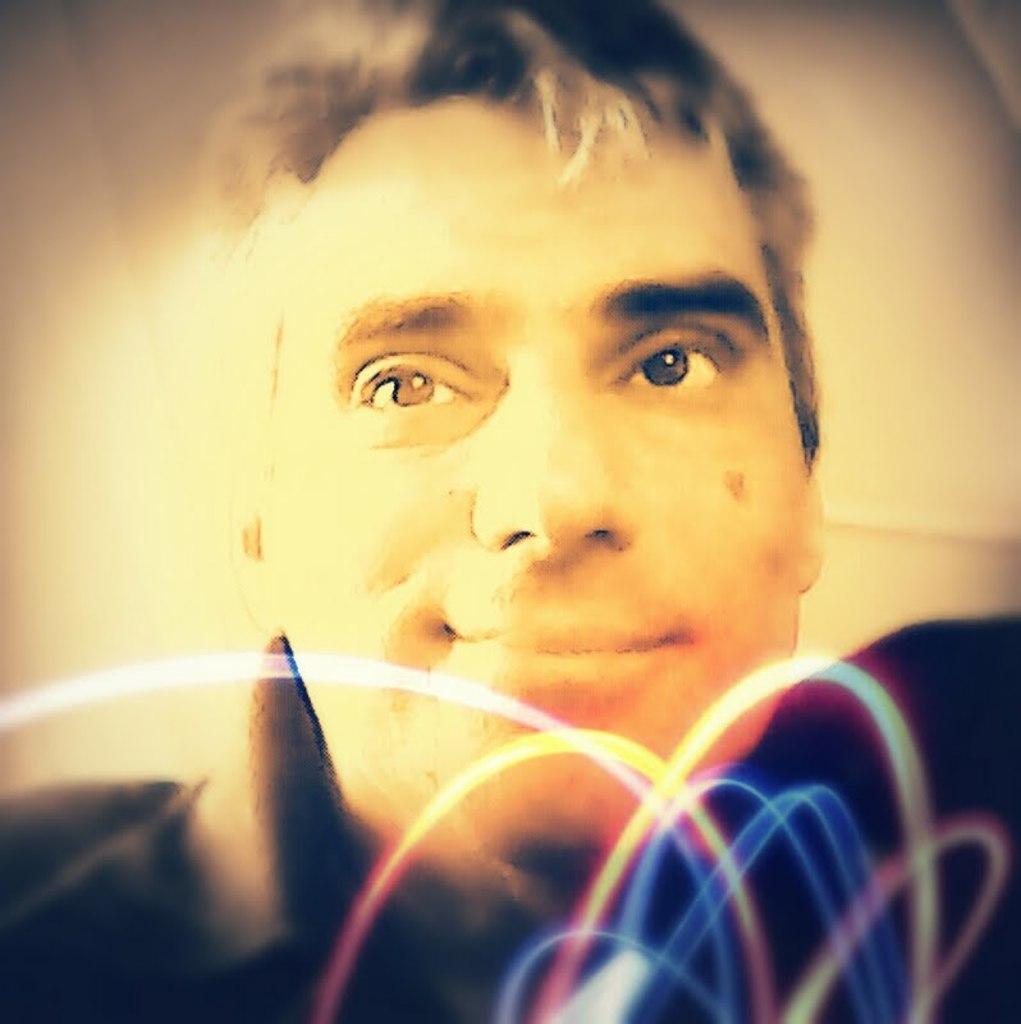Describe this image in one or two sentences. In this image we can see a man. 